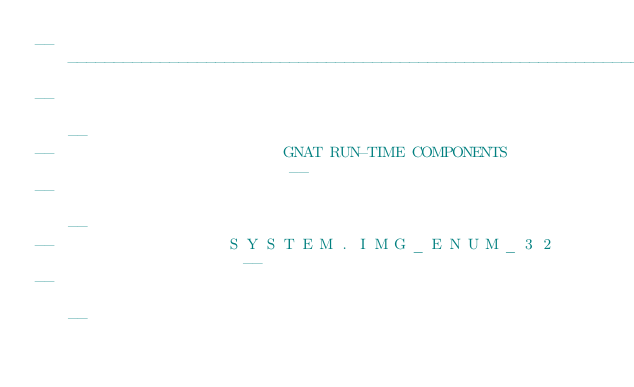<code> <loc_0><loc_0><loc_500><loc_500><_Ada_>------------------------------------------------------------------------------
--                                                                          --
--                         GNAT RUN-TIME COMPONENTS                         --
--                                                                          --
--                   S Y S T E M . I M G _ E N U M _ 3 2                    --
--                                                                          --</code> 